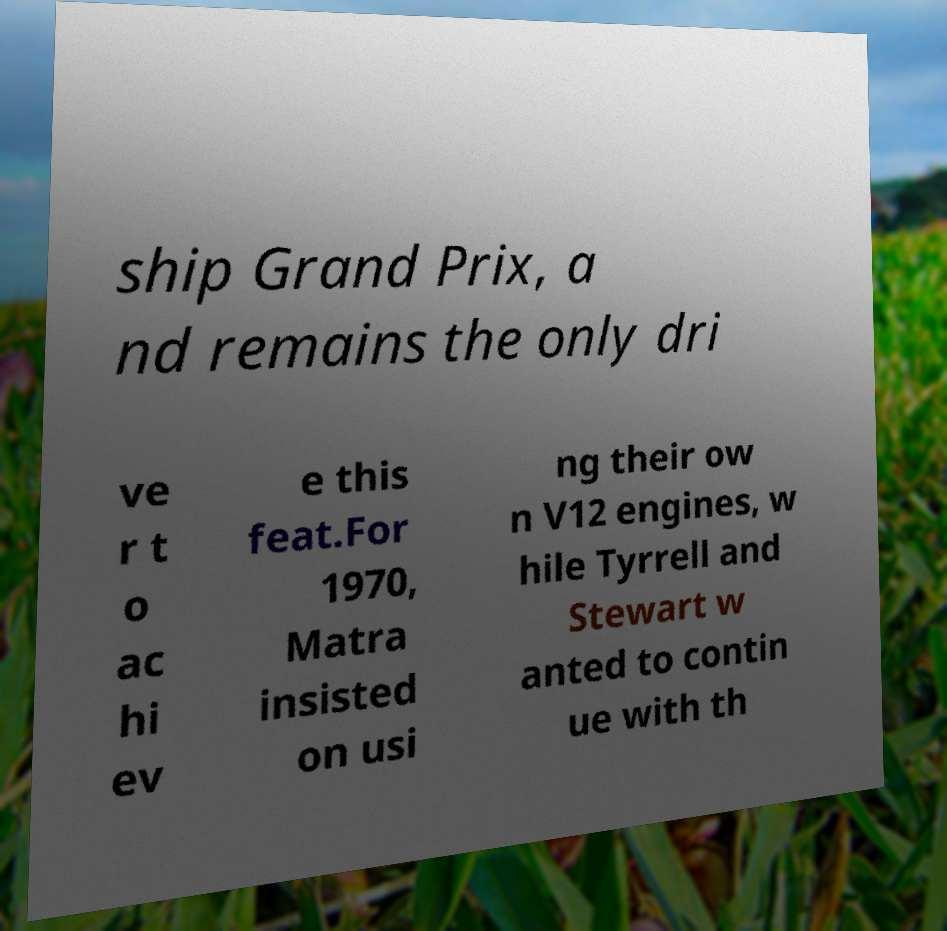I need the written content from this picture converted into text. Can you do that? ship Grand Prix, a nd remains the only dri ve r t o ac hi ev e this feat.For 1970, Matra insisted on usi ng their ow n V12 engines, w hile Tyrrell and Stewart w anted to contin ue with th 